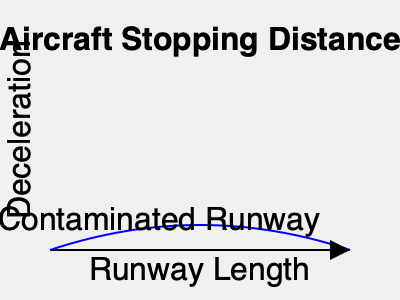As a pilot assessing runway conditions, you need to calculate the stopping distance for a Boeing 737-800 on a contaminated runway. Given the following parameters:

- Aircraft landing weight: 68,000 kg
- Approach speed: 140 knots
- Runway condition: 3mm standing water
- Runway slope: -0.5% (downhill)
- Outside air temperature: 15°C
- Pressure altitude: 1000 ft
- Wind: 10 knots headwind

Calculate the required stopping distance to the nearest meter. Assume the aircraft is equipped with autobrake setting 3 and reverse thrust is used. Use the following equation for the stopping distance calculation:

$$ S = \frac{V^2}{2a} + \frac{V^2}{2g(\mu \pm G)} $$

Where:
$S$ = Stopping distance (m)
$V$ = Approach speed (m/s)
$a$ = Deceleration rate due to braking (m/s²)
$g$ = Acceleration due to gravity (9.81 m/s²)
$\mu$ = Coefficient of friction (0.2 for 3mm standing water)
$G$ = Runway slope (as a decimal)

Note: The deceleration rate ($a$) for autobrake setting 3 is typically 4.3 m/s² for a Boeing 737-800. To solve this problem, we'll follow these steps:

1. Convert the approach speed from knots to m/s:
   140 knots = 140 * 0.5144 = 72.016 m/s

2. Account for the headwind:
   Groundspeed = Airspeed - Headwind
   72.016 - (10 * 0.5144) = 66.872 m/s

3. Use the given equation to calculate the stopping distance:
   $$ S = \frac{V^2}{2a} + \frac{V^2}{2g(\mu \pm G)} $$

   Where:
   $V = 66.872$ m/s
   $a = 4.3$ m/s²
   $g = 9.81$ m/s²
   $\mu = 0.2$
   $G = -0.005$ (negative because it's downhill)

4. Plug in the values:
   $$ S = \frac{66.872^2}{2(4.3)} + \frac{66.872^2}{2(9.81)(0.2 - 0.005)} $$

5. Calculate each part separately:
   Part 1: $\frac{66.872^2}{2(4.3)} = 520.37$ m
   Part 2: $\frac{66.872^2}{2(9.81)(0.2 - 0.005)} = 1161.36$ m

6. Sum the parts:
   $S = 520.37 + 1161.36 = 1681.73$ m

7. Round to the nearest meter:
   $S ≈ 1682$ m

Therefore, the required stopping distance for the Boeing 737-800 under the given conditions is approximately 1682 meters.
Answer: 1682 meters 